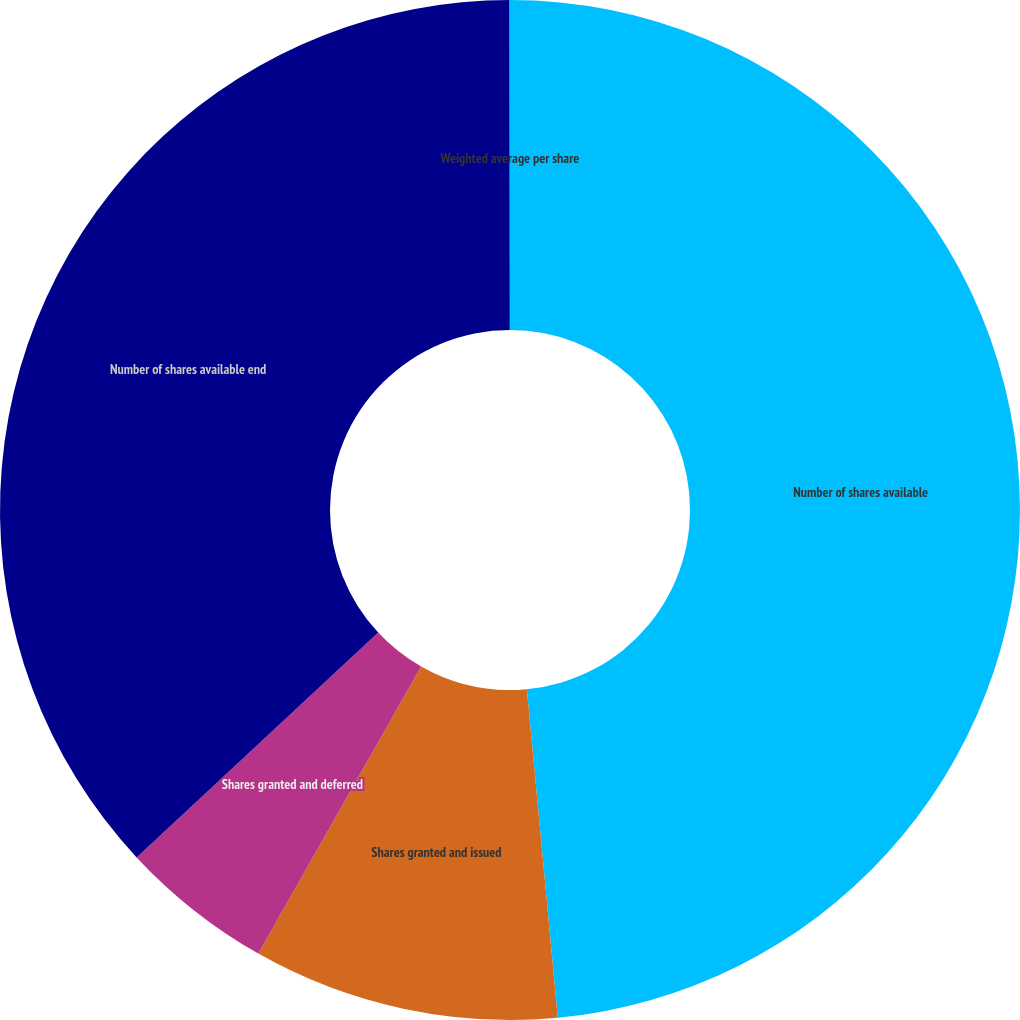<chart> <loc_0><loc_0><loc_500><loc_500><pie_chart><fcel>Number of shares available<fcel>Shares granted and issued<fcel>Shares granted and deferred<fcel>Number of shares available end<fcel>Weighted average per share<nl><fcel>48.51%<fcel>9.71%<fcel>4.86%<fcel>36.92%<fcel>0.01%<nl></chart> 